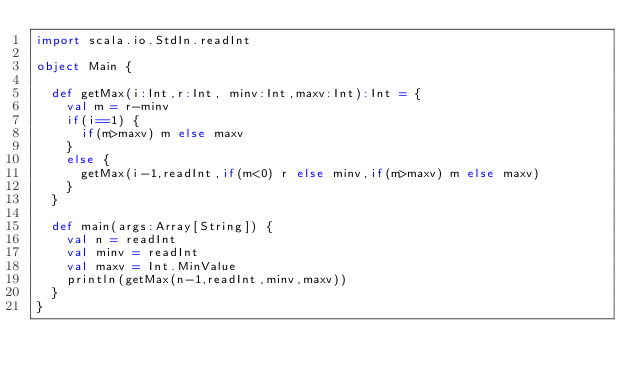Convert code to text. <code><loc_0><loc_0><loc_500><loc_500><_Scala_>import scala.io.StdIn.readInt

object Main {

  def getMax(i:Int,r:Int, minv:Int,maxv:Int):Int = {
    val m = r-minv
    if(i==1) {
      if(m>maxv) m else maxv
    }
    else {
      getMax(i-1,readInt,if(m<0) r else minv,if(m>maxv) m else maxv)
    }
  }

  def main(args:Array[String]) {
    val n = readInt
    val minv = readInt
    val maxv = Int.MinValue
    println(getMax(n-1,readInt,minv,maxv))
  }
}</code> 